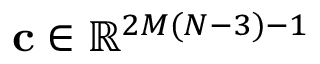<formula> <loc_0><loc_0><loc_500><loc_500>c \in \mathbb { R } ^ { 2 M ( N - 3 ) - 1 }</formula> 